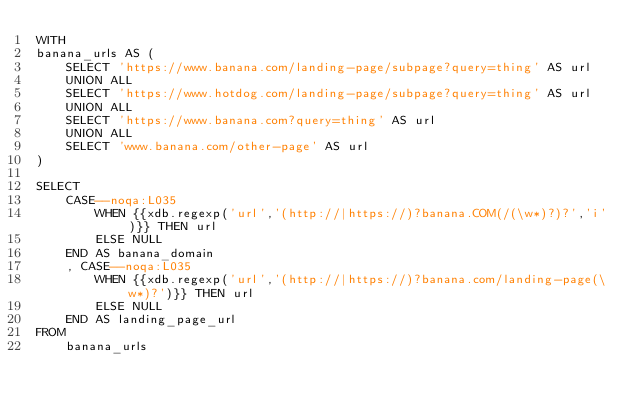<code> <loc_0><loc_0><loc_500><loc_500><_SQL_>WITH
banana_urls AS (
    SELECT 'https://www.banana.com/landing-page/subpage?query=thing' AS url
    UNION ALL
    SELECT 'https://www.hotdog.com/landing-page/subpage?query=thing' AS url
    UNION ALL
    SELECT 'https://www.banana.com?query=thing' AS url
    UNION ALL
    SELECT 'www.banana.com/other-page' AS url
)

SELECT
    CASE--noqa:L035
        WHEN {{xdb.regexp('url','(http://|https://)?banana.COM(/(\w*)?)?','i')}} THEN url
        ELSE NULL
    END AS banana_domain
    , CASE--noqa:L035
        WHEN {{xdb.regexp('url','(http://|https://)?banana.com/landing-page(\w*)?')}} THEN url
        ELSE NULL
    END AS landing_page_url
FROM
    banana_urls
</code> 